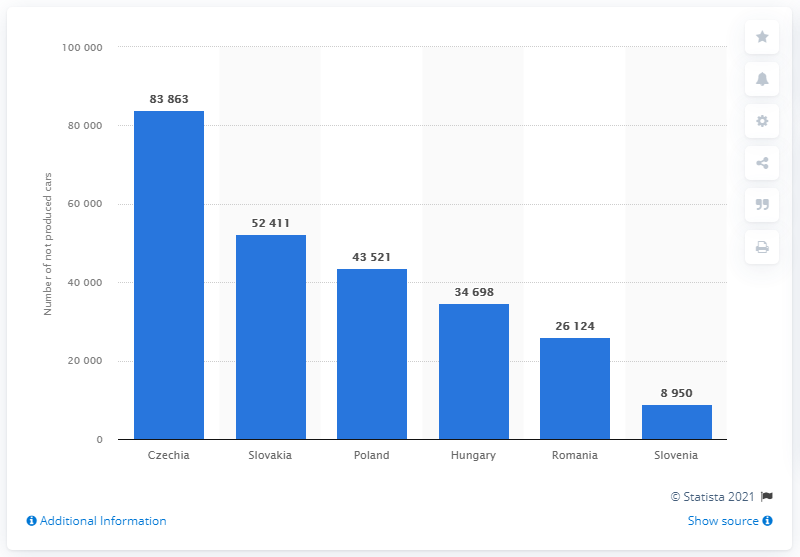Specify some key components in this picture. As of March 2020, the Czech Republic did not produce a total of 83,863 cars. 